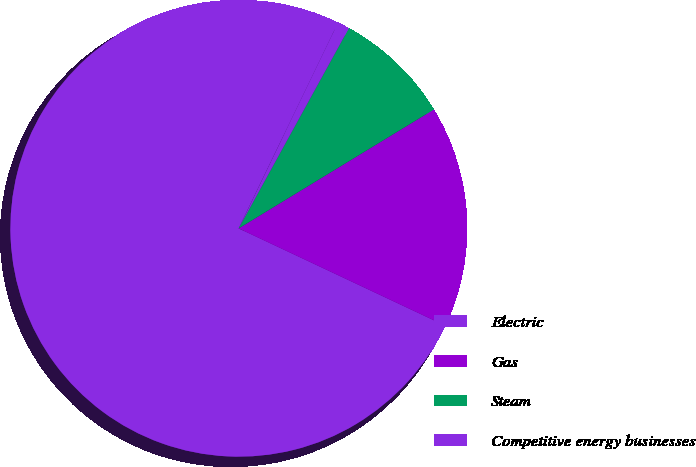Convert chart. <chart><loc_0><loc_0><loc_500><loc_500><pie_chart><fcel>Electric<fcel>Gas<fcel>Steam<fcel>Competitive energy businesses<nl><fcel>75.16%<fcel>15.71%<fcel>8.28%<fcel>0.85%<nl></chart> 